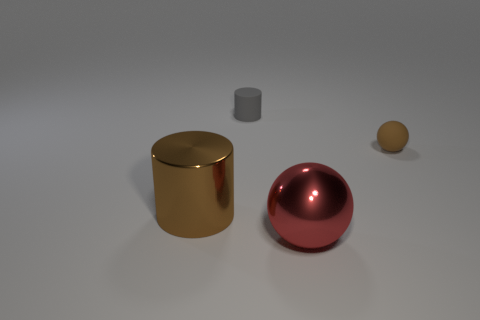How many things are brown things to the left of the tiny gray cylinder or big objects to the left of the tiny gray cylinder?
Provide a succinct answer. 1. Is the tiny ball the same color as the large sphere?
Your answer should be compact. No. Are there fewer brown metallic things than red metal cylinders?
Provide a short and direct response. No. Are there any large brown metallic things on the right side of the metallic sphere?
Your response must be concise. No. Is the material of the small brown thing the same as the gray cylinder?
Provide a short and direct response. Yes. There is a large metal thing that is the same shape as the small gray object; what is its color?
Offer a terse response. Brown. There is a sphere that is in front of the rubber sphere; is it the same color as the large metallic cylinder?
Ensure brevity in your answer.  No. There is a big shiny thing that is the same color as the tiny sphere; what is its shape?
Offer a very short reply. Cylinder. How many small brown things are made of the same material as the gray object?
Make the answer very short. 1. How many rubber things are on the left side of the small brown matte thing?
Your response must be concise. 1. 